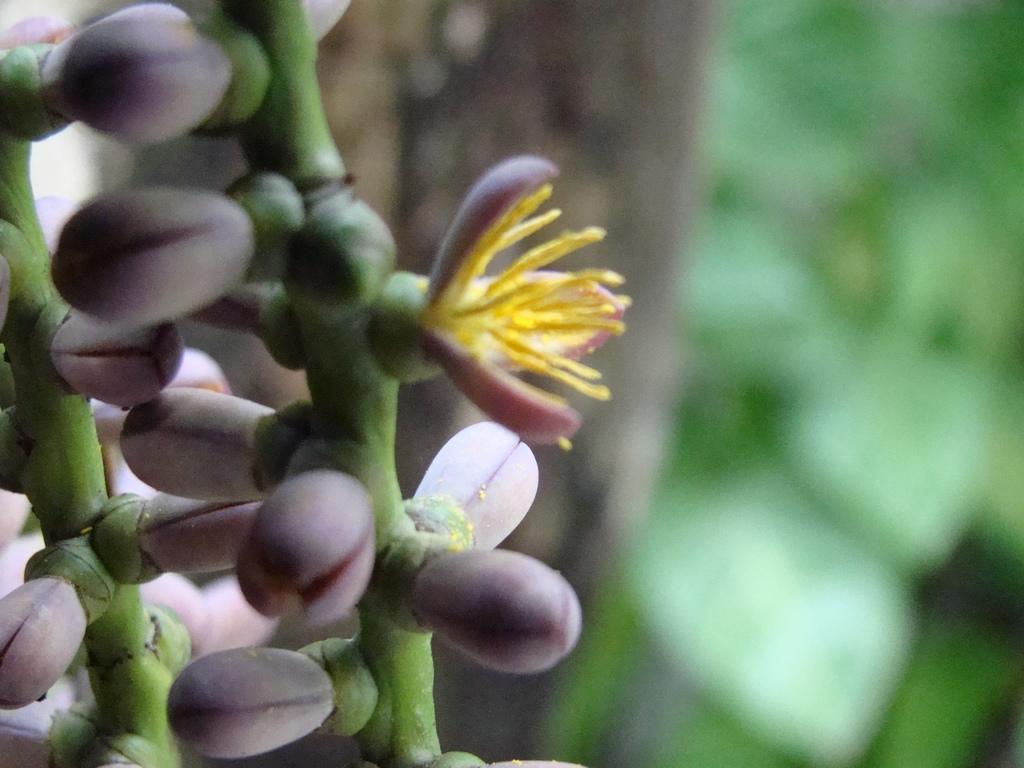Can you describe this image briefly? In this image we can see a plant to which some pink color flowers are grown and the background is blurry. 